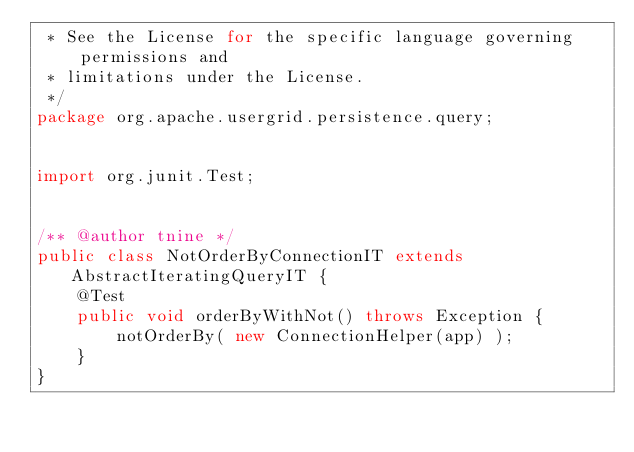<code> <loc_0><loc_0><loc_500><loc_500><_Java_> * See the License for the specific language governing permissions and
 * limitations under the License.
 */
package org.apache.usergrid.persistence.query;


import org.junit.Test;


/** @author tnine */
public class NotOrderByConnectionIT extends AbstractIteratingQueryIT {
    @Test
    public void orderByWithNot() throws Exception {
        notOrderBy( new ConnectionHelper(app) );
    }
}
</code> 